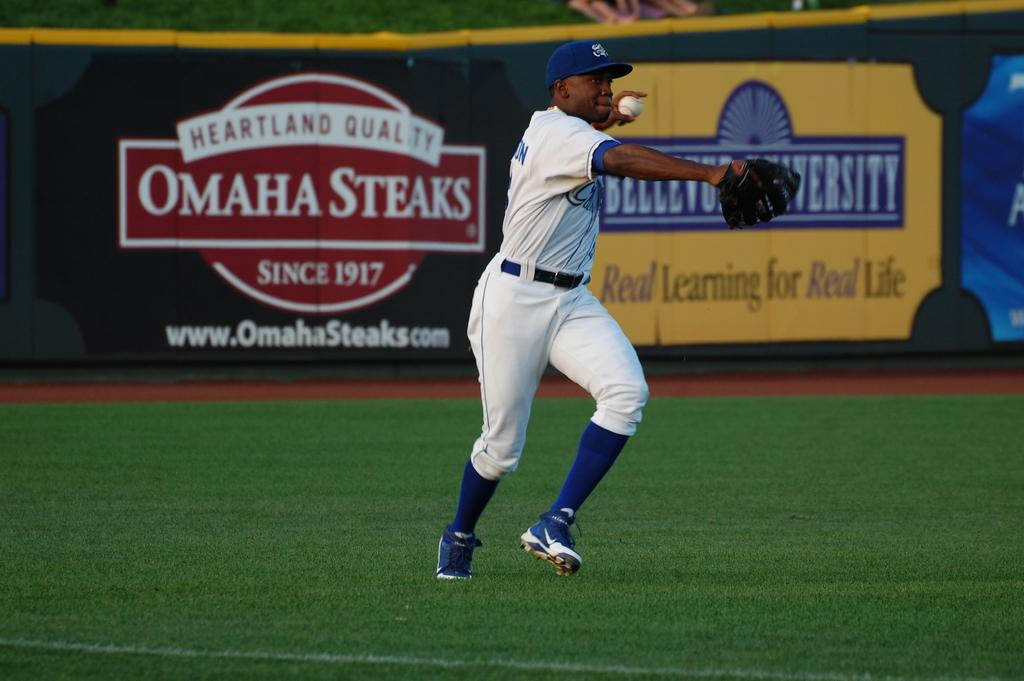Provide a one-sentence caption for the provided image. An ad for Omaha Steaks sits next to a yellow ad in the ballpark. 